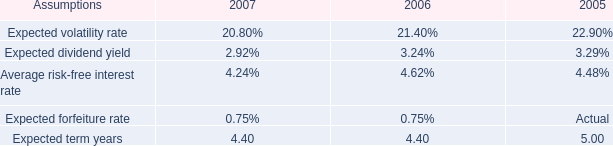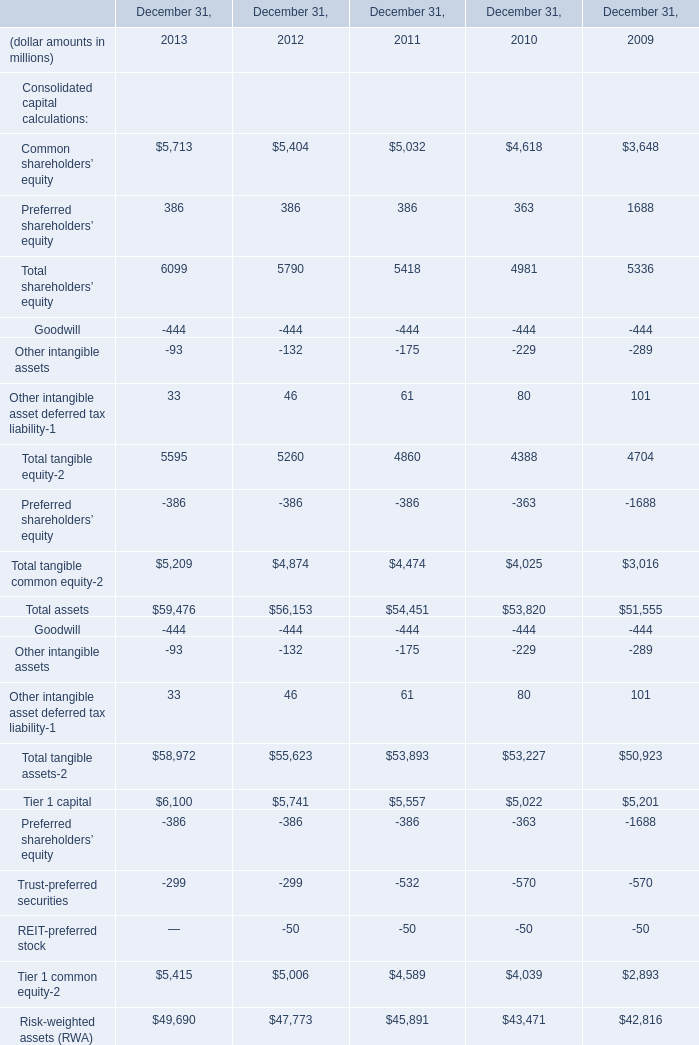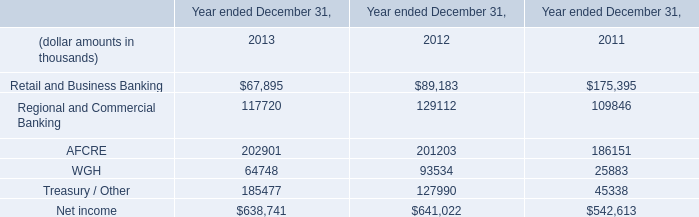If Common shareholders’ equity develops with the same increasing rate in 2012, what will it reach in 2013? (in million) 
Computations: ((1 + ((5404 - 5032) / 5032)) * 5404)
Answer: 5803.50079. 